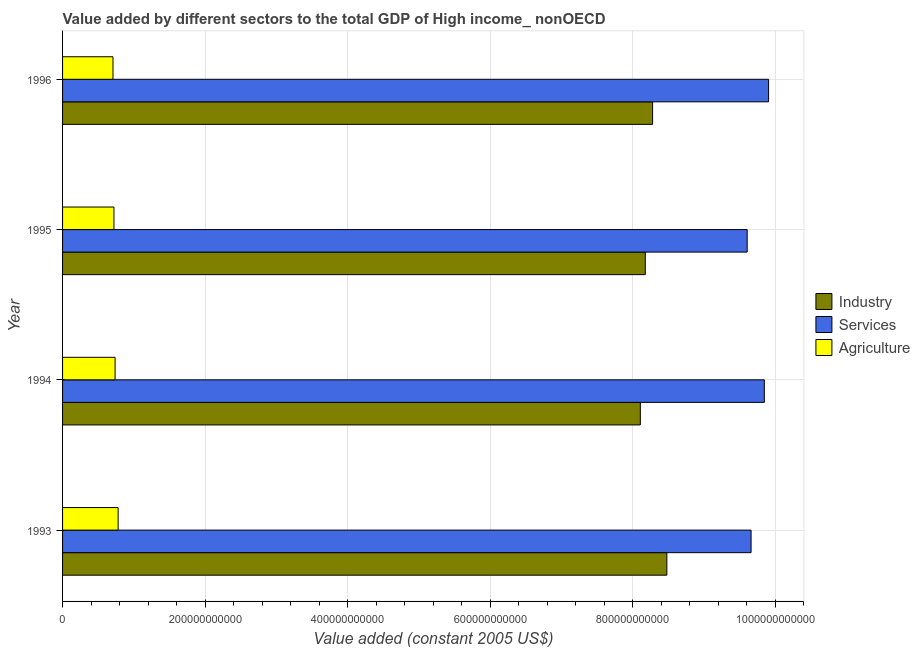How many different coloured bars are there?
Provide a succinct answer. 3. Are the number of bars per tick equal to the number of legend labels?
Your response must be concise. Yes. Are the number of bars on each tick of the Y-axis equal?
Offer a very short reply. Yes. What is the value added by services in 1995?
Your answer should be compact. 9.61e+11. Across all years, what is the maximum value added by industrial sector?
Provide a succinct answer. 8.48e+11. Across all years, what is the minimum value added by industrial sector?
Offer a very short reply. 8.11e+11. In which year was the value added by services minimum?
Offer a terse response. 1995. What is the total value added by services in the graph?
Offer a terse response. 3.90e+12. What is the difference between the value added by agricultural sector in 1995 and that in 1996?
Ensure brevity in your answer.  1.36e+09. What is the difference between the value added by agricultural sector in 1995 and the value added by services in 1994?
Ensure brevity in your answer.  -9.13e+11. What is the average value added by services per year?
Your answer should be very brief. 9.76e+11. In the year 1995, what is the difference between the value added by agricultural sector and value added by services?
Offer a very short reply. -8.89e+11. In how many years, is the value added by agricultural sector greater than 960000000000 US$?
Your response must be concise. 0. Is the difference between the value added by industrial sector in 1994 and 1995 greater than the difference between the value added by agricultural sector in 1994 and 1995?
Give a very brief answer. No. What is the difference between the highest and the second highest value added by services?
Ensure brevity in your answer.  5.99e+09. What is the difference between the highest and the lowest value added by industrial sector?
Your answer should be very brief. 3.72e+1. In how many years, is the value added by agricultural sector greater than the average value added by agricultural sector taken over all years?
Your response must be concise. 2. Is the sum of the value added by industrial sector in 1995 and 1996 greater than the maximum value added by services across all years?
Your answer should be compact. Yes. What does the 3rd bar from the top in 1995 represents?
Give a very brief answer. Industry. What does the 2nd bar from the bottom in 1996 represents?
Make the answer very short. Services. Is it the case that in every year, the sum of the value added by industrial sector and value added by services is greater than the value added by agricultural sector?
Your answer should be very brief. Yes. How many bars are there?
Keep it short and to the point. 12. How many years are there in the graph?
Offer a very short reply. 4. What is the difference between two consecutive major ticks on the X-axis?
Keep it short and to the point. 2.00e+11. Are the values on the major ticks of X-axis written in scientific E-notation?
Provide a short and direct response. No. Does the graph contain any zero values?
Offer a terse response. No. Does the graph contain grids?
Make the answer very short. Yes. How many legend labels are there?
Ensure brevity in your answer.  3. What is the title of the graph?
Your answer should be very brief. Value added by different sectors to the total GDP of High income_ nonOECD. What is the label or title of the X-axis?
Offer a terse response. Value added (constant 2005 US$). What is the label or title of the Y-axis?
Offer a terse response. Year. What is the Value added (constant 2005 US$) of Industry in 1993?
Your answer should be compact. 8.48e+11. What is the Value added (constant 2005 US$) in Services in 1993?
Offer a terse response. 9.66e+11. What is the Value added (constant 2005 US$) of Agriculture in 1993?
Keep it short and to the point. 7.80e+1. What is the Value added (constant 2005 US$) in Industry in 1994?
Keep it short and to the point. 8.11e+11. What is the Value added (constant 2005 US$) of Services in 1994?
Your answer should be compact. 9.85e+11. What is the Value added (constant 2005 US$) in Agriculture in 1994?
Provide a succinct answer. 7.37e+1. What is the Value added (constant 2005 US$) in Industry in 1995?
Offer a very short reply. 8.18e+11. What is the Value added (constant 2005 US$) in Services in 1995?
Offer a very short reply. 9.61e+11. What is the Value added (constant 2005 US$) of Agriculture in 1995?
Your answer should be very brief. 7.21e+1. What is the Value added (constant 2005 US$) of Industry in 1996?
Provide a succinct answer. 8.28e+11. What is the Value added (constant 2005 US$) in Services in 1996?
Your answer should be compact. 9.91e+11. What is the Value added (constant 2005 US$) of Agriculture in 1996?
Your response must be concise. 7.07e+1. Across all years, what is the maximum Value added (constant 2005 US$) in Industry?
Offer a very short reply. 8.48e+11. Across all years, what is the maximum Value added (constant 2005 US$) of Services?
Make the answer very short. 9.91e+11. Across all years, what is the maximum Value added (constant 2005 US$) of Agriculture?
Keep it short and to the point. 7.80e+1. Across all years, what is the minimum Value added (constant 2005 US$) in Industry?
Offer a very short reply. 8.11e+11. Across all years, what is the minimum Value added (constant 2005 US$) in Services?
Provide a short and direct response. 9.61e+11. Across all years, what is the minimum Value added (constant 2005 US$) in Agriculture?
Provide a short and direct response. 7.07e+1. What is the total Value added (constant 2005 US$) of Industry in the graph?
Ensure brevity in your answer.  3.30e+12. What is the total Value added (constant 2005 US$) of Services in the graph?
Provide a succinct answer. 3.90e+12. What is the total Value added (constant 2005 US$) of Agriculture in the graph?
Ensure brevity in your answer.  2.95e+11. What is the difference between the Value added (constant 2005 US$) of Industry in 1993 and that in 1994?
Ensure brevity in your answer.  3.72e+1. What is the difference between the Value added (constant 2005 US$) in Services in 1993 and that in 1994?
Your answer should be very brief. -1.86e+1. What is the difference between the Value added (constant 2005 US$) of Agriculture in 1993 and that in 1994?
Offer a terse response. 4.29e+09. What is the difference between the Value added (constant 2005 US$) of Industry in 1993 and that in 1995?
Offer a very short reply. 3.02e+1. What is the difference between the Value added (constant 2005 US$) in Services in 1993 and that in 1995?
Provide a short and direct response. 5.44e+09. What is the difference between the Value added (constant 2005 US$) in Agriculture in 1993 and that in 1995?
Your answer should be compact. 5.86e+09. What is the difference between the Value added (constant 2005 US$) in Industry in 1993 and that in 1996?
Your response must be concise. 2.00e+1. What is the difference between the Value added (constant 2005 US$) of Services in 1993 and that in 1996?
Your answer should be compact. -2.46e+1. What is the difference between the Value added (constant 2005 US$) of Agriculture in 1993 and that in 1996?
Make the answer very short. 7.22e+09. What is the difference between the Value added (constant 2005 US$) in Industry in 1994 and that in 1995?
Keep it short and to the point. -6.98e+09. What is the difference between the Value added (constant 2005 US$) of Services in 1994 and that in 1995?
Your answer should be compact. 2.40e+1. What is the difference between the Value added (constant 2005 US$) in Agriculture in 1994 and that in 1995?
Keep it short and to the point. 1.57e+09. What is the difference between the Value added (constant 2005 US$) in Industry in 1994 and that in 1996?
Provide a succinct answer. -1.72e+1. What is the difference between the Value added (constant 2005 US$) of Services in 1994 and that in 1996?
Make the answer very short. -5.99e+09. What is the difference between the Value added (constant 2005 US$) of Agriculture in 1994 and that in 1996?
Your answer should be compact. 2.94e+09. What is the difference between the Value added (constant 2005 US$) of Industry in 1995 and that in 1996?
Ensure brevity in your answer.  -1.02e+1. What is the difference between the Value added (constant 2005 US$) in Services in 1995 and that in 1996?
Make the answer very short. -3.00e+1. What is the difference between the Value added (constant 2005 US$) in Agriculture in 1995 and that in 1996?
Give a very brief answer. 1.36e+09. What is the difference between the Value added (constant 2005 US$) of Industry in 1993 and the Value added (constant 2005 US$) of Services in 1994?
Your answer should be compact. -1.37e+11. What is the difference between the Value added (constant 2005 US$) in Industry in 1993 and the Value added (constant 2005 US$) in Agriculture in 1994?
Provide a succinct answer. 7.74e+11. What is the difference between the Value added (constant 2005 US$) in Services in 1993 and the Value added (constant 2005 US$) in Agriculture in 1994?
Keep it short and to the point. 8.92e+11. What is the difference between the Value added (constant 2005 US$) of Industry in 1993 and the Value added (constant 2005 US$) of Services in 1995?
Ensure brevity in your answer.  -1.13e+11. What is the difference between the Value added (constant 2005 US$) in Industry in 1993 and the Value added (constant 2005 US$) in Agriculture in 1995?
Offer a terse response. 7.76e+11. What is the difference between the Value added (constant 2005 US$) in Services in 1993 and the Value added (constant 2005 US$) in Agriculture in 1995?
Ensure brevity in your answer.  8.94e+11. What is the difference between the Value added (constant 2005 US$) in Industry in 1993 and the Value added (constant 2005 US$) in Services in 1996?
Your answer should be very brief. -1.43e+11. What is the difference between the Value added (constant 2005 US$) in Industry in 1993 and the Value added (constant 2005 US$) in Agriculture in 1996?
Provide a succinct answer. 7.77e+11. What is the difference between the Value added (constant 2005 US$) of Services in 1993 and the Value added (constant 2005 US$) of Agriculture in 1996?
Offer a very short reply. 8.95e+11. What is the difference between the Value added (constant 2005 US$) in Industry in 1994 and the Value added (constant 2005 US$) in Services in 1995?
Offer a terse response. -1.50e+11. What is the difference between the Value added (constant 2005 US$) in Industry in 1994 and the Value added (constant 2005 US$) in Agriculture in 1995?
Offer a very short reply. 7.39e+11. What is the difference between the Value added (constant 2005 US$) in Services in 1994 and the Value added (constant 2005 US$) in Agriculture in 1995?
Your answer should be compact. 9.13e+11. What is the difference between the Value added (constant 2005 US$) of Industry in 1994 and the Value added (constant 2005 US$) of Services in 1996?
Make the answer very short. -1.80e+11. What is the difference between the Value added (constant 2005 US$) of Industry in 1994 and the Value added (constant 2005 US$) of Agriculture in 1996?
Keep it short and to the point. 7.40e+11. What is the difference between the Value added (constant 2005 US$) of Services in 1994 and the Value added (constant 2005 US$) of Agriculture in 1996?
Give a very brief answer. 9.14e+11. What is the difference between the Value added (constant 2005 US$) of Industry in 1995 and the Value added (constant 2005 US$) of Services in 1996?
Keep it short and to the point. -1.73e+11. What is the difference between the Value added (constant 2005 US$) in Industry in 1995 and the Value added (constant 2005 US$) in Agriculture in 1996?
Give a very brief answer. 7.47e+11. What is the difference between the Value added (constant 2005 US$) in Services in 1995 and the Value added (constant 2005 US$) in Agriculture in 1996?
Ensure brevity in your answer.  8.90e+11. What is the average Value added (constant 2005 US$) of Industry per year?
Keep it short and to the point. 8.26e+11. What is the average Value added (constant 2005 US$) of Services per year?
Make the answer very short. 9.76e+11. What is the average Value added (constant 2005 US$) of Agriculture per year?
Your answer should be compact. 7.36e+1. In the year 1993, what is the difference between the Value added (constant 2005 US$) of Industry and Value added (constant 2005 US$) of Services?
Your response must be concise. -1.18e+11. In the year 1993, what is the difference between the Value added (constant 2005 US$) of Industry and Value added (constant 2005 US$) of Agriculture?
Your response must be concise. 7.70e+11. In the year 1993, what is the difference between the Value added (constant 2005 US$) of Services and Value added (constant 2005 US$) of Agriculture?
Your response must be concise. 8.88e+11. In the year 1994, what is the difference between the Value added (constant 2005 US$) of Industry and Value added (constant 2005 US$) of Services?
Your answer should be very brief. -1.74e+11. In the year 1994, what is the difference between the Value added (constant 2005 US$) in Industry and Value added (constant 2005 US$) in Agriculture?
Your answer should be compact. 7.37e+11. In the year 1994, what is the difference between the Value added (constant 2005 US$) of Services and Value added (constant 2005 US$) of Agriculture?
Your response must be concise. 9.11e+11. In the year 1995, what is the difference between the Value added (constant 2005 US$) in Industry and Value added (constant 2005 US$) in Services?
Provide a succinct answer. -1.43e+11. In the year 1995, what is the difference between the Value added (constant 2005 US$) in Industry and Value added (constant 2005 US$) in Agriculture?
Provide a short and direct response. 7.46e+11. In the year 1995, what is the difference between the Value added (constant 2005 US$) in Services and Value added (constant 2005 US$) in Agriculture?
Your response must be concise. 8.89e+11. In the year 1996, what is the difference between the Value added (constant 2005 US$) of Industry and Value added (constant 2005 US$) of Services?
Give a very brief answer. -1.63e+11. In the year 1996, what is the difference between the Value added (constant 2005 US$) of Industry and Value added (constant 2005 US$) of Agriculture?
Your answer should be very brief. 7.57e+11. In the year 1996, what is the difference between the Value added (constant 2005 US$) of Services and Value added (constant 2005 US$) of Agriculture?
Offer a very short reply. 9.20e+11. What is the ratio of the Value added (constant 2005 US$) in Industry in 1993 to that in 1994?
Your response must be concise. 1.05. What is the ratio of the Value added (constant 2005 US$) of Services in 1993 to that in 1994?
Offer a very short reply. 0.98. What is the ratio of the Value added (constant 2005 US$) of Agriculture in 1993 to that in 1994?
Your response must be concise. 1.06. What is the ratio of the Value added (constant 2005 US$) of Industry in 1993 to that in 1995?
Your answer should be very brief. 1.04. What is the ratio of the Value added (constant 2005 US$) of Services in 1993 to that in 1995?
Provide a succinct answer. 1.01. What is the ratio of the Value added (constant 2005 US$) in Agriculture in 1993 to that in 1995?
Provide a short and direct response. 1.08. What is the ratio of the Value added (constant 2005 US$) of Industry in 1993 to that in 1996?
Offer a very short reply. 1.02. What is the ratio of the Value added (constant 2005 US$) in Services in 1993 to that in 1996?
Offer a very short reply. 0.98. What is the ratio of the Value added (constant 2005 US$) of Agriculture in 1993 to that in 1996?
Provide a short and direct response. 1.1. What is the ratio of the Value added (constant 2005 US$) in Industry in 1994 to that in 1995?
Your answer should be very brief. 0.99. What is the ratio of the Value added (constant 2005 US$) of Services in 1994 to that in 1995?
Your response must be concise. 1.02. What is the ratio of the Value added (constant 2005 US$) of Agriculture in 1994 to that in 1995?
Provide a short and direct response. 1.02. What is the ratio of the Value added (constant 2005 US$) in Industry in 1994 to that in 1996?
Ensure brevity in your answer.  0.98. What is the ratio of the Value added (constant 2005 US$) in Services in 1994 to that in 1996?
Provide a short and direct response. 0.99. What is the ratio of the Value added (constant 2005 US$) of Agriculture in 1994 to that in 1996?
Provide a short and direct response. 1.04. What is the ratio of the Value added (constant 2005 US$) in Industry in 1995 to that in 1996?
Your response must be concise. 0.99. What is the ratio of the Value added (constant 2005 US$) in Services in 1995 to that in 1996?
Offer a terse response. 0.97. What is the ratio of the Value added (constant 2005 US$) in Agriculture in 1995 to that in 1996?
Make the answer very short. 1.02. What is the difference between the highest and the second highest Value added (constant 2005 US$) of Industry?
Make the answer very short. 2.00e+1. What is the difference between the highest and the second highest Value added (constant 2005 US$) in Services?
Ensure brevity in your answer.  5.99e+09. What is the difference between the highest and the second highest Value added (constant 2005 US$) in Agriculture?
Ensure brevity in your answer.  4.29e+09. What is the difference between the highest and the lowest Value added (constant 2005 US$) in Industry?
Offer a very short reply. 3.72e+1. What is the difference between the highest and the lowest Value added (constant 2005 US$) of Services?
Provide a succinct answer. 3.00e+1. What is the difference between the highest and the lowest Value added (constant 2005 US$) in Agriculture?
Your response must be concise. 7.22e+09. 